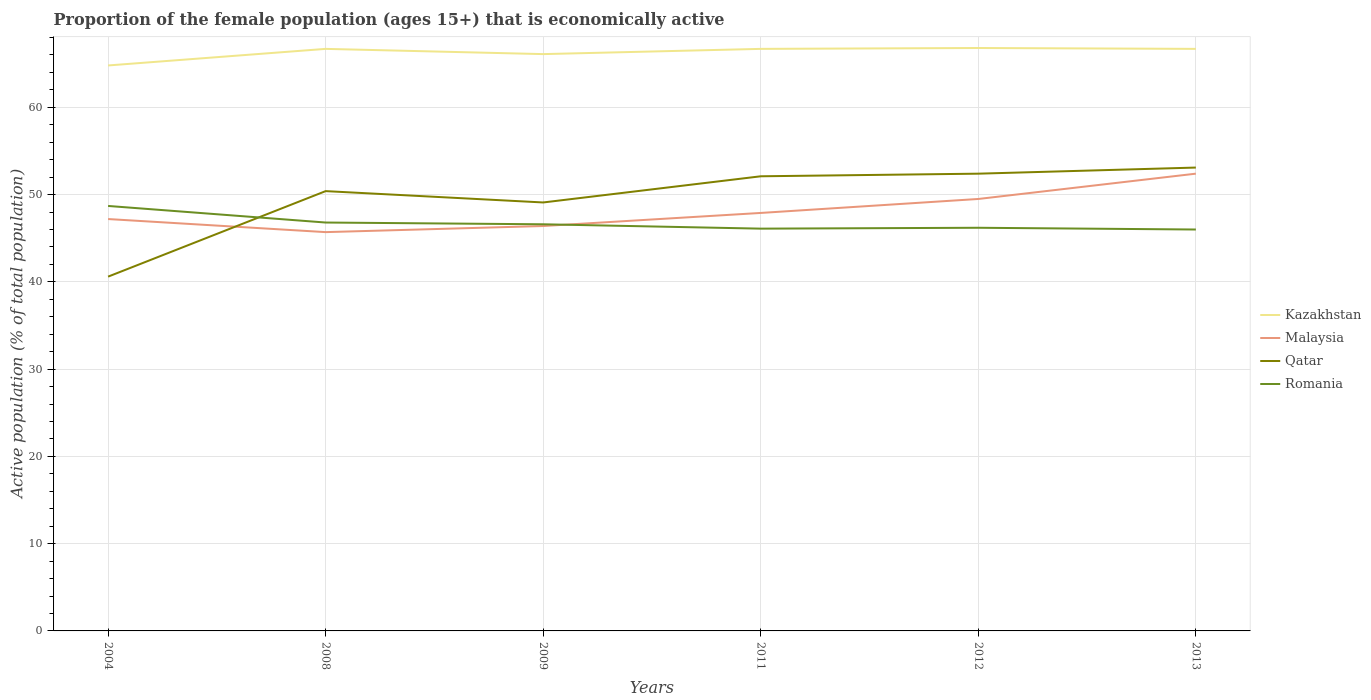Does the line corresponding to Malaysia intersect with the line corresponding to Qatar?
Your response must be concise. Yes. What is the total proportion of the female population that is economically active in Qatar in the graph?
Your answer should be very brief. -1. What is the difference between the highest and the lowest proportion of the female population that is economically active in Qatar?
Your answer should be very brief. 4. How many lines are there?
Make the answer very short. 4. How many years are there in the graph?
Make the answer very short. 6. What is the difference between two consecutive major ticks on the Y-axis?
Your response must be concise. 10. Are the values on the major ticks of Y-axis written in scientific E-notation?
Ensure brevity in your answer.  No. Where does the legend appear in the graph?
Provide a succinct answer. Center right. How many legend labels are there?
Your answer should be very brief. 4. How are the legend labels stacked?
Ensure brevity in your answer.  Vertical. What is the title of the graph?
Provide a short and direct response. Proportion of the female population (ages 15+) that is economically active. Does "Europe(developing only)" appear as one of the legend labels in the graph?
Provide a short and direct response. No. What is the label or title of the Y-axis?
Give a very brief answer. Active population (% of total population). What is the Active population (% of total population) of Kazakhstan in 2004?
Make the answer very short. 64.8. What is the Active population (% of total population) in Malaysia in 2004?
Provide a succinct answer. 47.2. What is the Active population (% of total population) in Qatar in 2004?
Keep it short and to the point. 40.6. What is the Active population (% of total population) in Romania in 2004?
Your answer should be very brief. 48.7. What is the Active population (% of total population) in Kazakhstan in 2008?
Give a very brief answer. 66.7. What is the Active population (% of total population) of Malaysia in 2008?
Provide a short and direct response. 45.7. What is the Active population (% of total population) of Qatar in 2008?
Ensure brevity in your answer.  50.4. What is the Active population (% of total population) of Romania in 2008?
Provide a short and direct response. 46.8. What is the Active population (% of total population) of Kazakhstan in 2009?
Your answer should be compact. 66.1. What is the Active population (% of total population) of Malaysia in 2009?
Your answer should be very brief. 46.4. What is the Active population (% of total population) in Qatar in 2009?
Your response must be concise. 49.1. What is the Active population (% of total population) in Romania in 2009?
Offer a very short reply. 46.6. What is the Active population (% of total population) in Kazakhstan in 2011?
Your answer should be very brief. 66.7. What is the Active population (% of total population) of Malaysia in 2011?
Provide a succinct answer. 47.9. What is the Active population (% of total population) of Qatar in 2011?
Your response must be concise. 52.1. What is the Active population (% of total population) in Romania in 2011?
Your answer should be very brief. 46.1. What is the Active population (% of total population) in Kazakhstan in 2012?
Make the answer very short. 66.8. What is the Active population (% of total population) of Malaysia in 2012?
Offer a very short reply. 49.5. What is the Active population (% of total population) in Qatar in 2012?
Your answer should be compact. 52.4. What is the Active population (% of total population) of Romania in 2012?
Your answer should be very brief. 46.2. What is the Active population (% of total population) of Kazakhstan in 2013?
Ensure brevity in your answer.  66.7. What is the Active population (% of total population) in Malaysia in 2013?
Offer a very short reply. 52.4. What is the Active population (% of total population) of Qatar in 2013?
Offer a terse response. 53.1. What is the Active population (% of total population) of Romania in 2013?
Offer a very short reply. 46. Across all years, what is the maximum Active population (% of total population) of Kazakhstan?
Your answer should be very brief. 66.8. Across all years, what is the maximum Active population (% of total population) in Malaysia?
Offer a very short reply. 52.4. Across all years, what is the maximum Active population (% of total population) of Qatar?
Your answer should be very brief. 53.1. Across all years, what is the maximum Active population (% of total population) of Romania?
Make the answer very short. 48.7. Across all years, what is the minimum Active population (% of total population) in Kazakhstan?
Give a very brief answer. 64.8. Across all years, what is the minimum Active population (% of total population) of Malaysia?
Offer a terse response. 45.7. Across all years, what is the minimum Active population (% of total population) of Qatar?
Provide a succinct answer. 40.6. Across all years, what is the minimum Active population (% of total population) of Romania?
Your answer should be very brief. 46. What is the total Active population (% of total population) in Kazakhstan in the graph?
Provide a succinct answer. 397.8. What is the total Active population (% of total population) in Malaysia in the graph?
Keep it short and to the point. 289.1. What is the total Active population (% of total population) of Qatar in the graph?
Give a very brief answer. 297.7. What is the total Active population (% of total population) of Romania in the graph?
Make the answer very short. 280.4. What is the difference between the Active population (% of total population) of Malaysia in 2004 and that in 2008?
Your answer should be compact. 1.5. What is the difference between the Active population (% of total population) in Qatar in 2004 and that in 2008?
Make the answer very short. -9.8. What is the difference between the Active population (% of total population) of Romania in 2004 and that in 2008?
Your response must be concise. 1.9. What is the difference between the Active population (% of total population) of Romania in 2004 and that in 2009?
Your response must be concise. 2.1. What is the difference between the Active population (% of total population) of Kazakhstan in 2004 and that in 2011?
Ensure brevity in your answer.  -1.9. What is the difference between the Active population (% of total population) of Malaysia in 2004 and that in 2011?
Offer a terse response. -0.7. What is the difference between the Active population (% of total population) of Qatar in 2004 and that in 2011?
Your response must be concise. -11.5. What is the difference between the Active population (% of total population) in Kazakhstan in 2004 and that in 2012?
Your response must be concise. -2. What is the difference between the Active population (% of total population) of Qatar in 2004 and that in 2012?
Provide a short and direct response. -11.8. What is the difference between the Active population (% of total population) in Malaysia in 2004 and that in 2013?
Provide a succinct answer. -5.2. What is the difference between the Active population (% of total population) of Romania in 2004 and that in 2013?
Give a very brief answer. 2.7. What is the difference between the Active population (% of total population) in Kazakhstan in 2008 and that in 2009?
Your response must be concise. 0.6. What is the difference between the Active population (% of total population) in Qatar in 2008 and that in 2009?
Give a very brief answer. 1.3. What is the difference between the Active population (% of total population) in Romania in 2008 and that in 2009?
Your answer should be very brief. 0.2. What is the difference between the Active population (% of total population) of Kazakhstan in 2008 and that in 2011?
Provide a succinct answer. 0. What is the difference between the Active population (% of total population) of Malaysia in 2008 and that in 2011?
Your answer should be compact. -2.2. What is the difference between the Active population (% of total population) in Romania in 2008 and that in 2011?
Your response must be concise. 0.7. What is the difference between the Active population (% of total population) in Malaysia in 2008 and that in 2012?
Give a very brief answer. -3.8. What is the difference between the Active population (% of total population) in Malaysia in 2008 and that in 2013?
Offer a terse response. -6.7. What is the difference between the Active population (% of total population) in Malaysia in 2009 and that in 2011?
Ensure brevity in your answer.  -1.5. What is the difference between the Active population (% of total population) in Qatar in 2009 and that in 2011?
Offer a very short reply. -3. What is the difference between the Active population (% of total population) of Romania in 2011 and that in 2012?
Ensure brevity in your answer.  -0.1. What is the difference between the Active population (% of total population) of Kazakhstan in 2011 and that in 2013?
Your answer should be very brief. 0. What is the difference between the Active population (% of total population) in Malaysia in 2011 and that in 2013?
Provide a short and direct response. -4.5. What is the difference between the Active population (% of total population) of Romania in 2011 and that in 2013?
Provide a succinct answer. 0.1. What is the difference between the Active population (% of total population) in Qatar in 2012 and that in 2013?
Make the answer very short. -0.7. What is the difference between the Active population (% of total population) of Romania in 2012 and that in 2013?
Offer a terse response. 0.2. What is the difference between the Active population (% of total population) of Kazakhstan in 2004 and the Active population (% of total population) of Malaysia in 2008?
Your answer should be compact. 19.1. What is the difference between the Active population (% of total population) of Kazakhstan in 2004 and the Active population (% of total population) of Malaysia in 2009?
Offer a terse response. 18.4. What is the difference between the Active population (% of total population) in Kazakhstan in 2004 and the Active population (% of total population) in Qatar in 2009?
Your response must be concise. 15.7. What is the difference between the Active population (% of total population) of Kazakhstan in 2004 and the Active population (% of total population) of Romania in 2009?
Make the answer very short. 18.2. What is the difference between the Active population (% of total population) of Malaysia in 2004 and the Active population (% of total population) of Qatar in 2009?
Offer a terse response. -1.9. What is the difference between the Active population (% of total population) of Qatar in 2004 and the Active population (% of total population) of Romania in 2009?
Keep it short and to the point. -6. What is the difference between the Active population (% of total population) of Kazakhstan in 2004 and the Active population (% of total population) of Malaysia in 2011?
Offer a very short reply. 16.9. What is the difference between the Active population (% of total population) of Kazakhstan in 2004 and the Active population (% of total population) of Qatar in 2011?
Offer a terse response. 12.7. What is the difference between the Active population (% of total population) in Malaysia in 2004 and the Active population (% of total population) in Romania in 2011?
Your answer should be very brief. 1.1. What is the difference between the Active population (% of total population) of Qatar in 2004 and the Active population (% of total population) of Romania in 2011?
Keep it short and to the point. -5.5. What is the difference between the Active population (% of total population) of Malaysia in 2004 and the Active population (% of total population) of Qatar in 2012?
Ensure brevity in your answer.  -5.2. What is the difference between the Active population (% of total population) of Kazakhstan in 2004 and the Active population (% of total population) of Malaysia in 2013?
Your answer should be compact. 12.4. What is the difference between the Active population (% of total population) of Malaysia in 2004 and the Active population (% of total population) of Romania in 2013?
Offer a terse response. 1.2. What is the difference between the Active population (% of total population) in Kazakhstan in 2008 and the Active population (% of total population) in Malaysia in 2009?
Offer a very short reply. 20.3. What is the difference between the Active population (% of total population) of Kazakhstan in 2008 and the Active population (% of total population) of Qatar in 2009?
Ensure brevity in your answer.  17.6. What is the difference between the Active population (% of total population) in Kazakhstan in 2008 and the Active population (% of total population) in Romania in 2009?
Your answer should be very brief. 20.1. What is the difference between the Active population (% of total population) of Malaysia in 2008 and the Active population (% of total population) of Qatar in 2009?
Make the answer very short. -3.4. What is the difference between the Active population (% of total population) of Qatar in 2008 and the Active population (% of total population) of Romania in 2009?
Your answer should be very brief. 3.8. What is the difference between the Active population (% of total population) in Kazakhstan in 2008 and the Active population (% of total population) in Romania in 2011?
Give a very brief answer. 20.6. What is the difference between the Active population (% of total population) in Malaysia in 2008 and the Active population (% of total population) in Qatar in 2011?
Provide a succinct answer. -6.4. What is the difference between the Active population (% of total population) in Malaysia in 2008 and the Active population (% of total population) in Romania in 2011?
Your response must be concise. -0.4. What is the difference between the Active population (% of total population) in Kazakhstan in 2008 and the Active population (% of total population) in Romania in 2012?
Your answer should be very brief. 20.5. What is the difference between the Active population (% of total population) of Malaysia in 2008 and the Active population (% of total population) of Qatar in 2012?
Your response must be concise. -6.7. What is the difference between the Active population (% of total population) of Qatar in 2008 and the Active population (% of total population) of Romania in 2012?
Keep it short and to the point. 4.2. What is the difference between the Active population (% of total population) of Kazakhstan in 2008 and the Active population (% of total population) of Romania in 2013?
Give a very brief answer. 20.7. What is the difference between the Active population (% of total population) in Malaysia in 2008 and the Active population (% of total population) in Qatar in 2013?
Provide a succinct answer. -7.4. What is the difference between the Active population (% of total population) in Qatar in 2008 and the Active population (% of total population) in Romania in 2013?
Ensure brevity in your answer.  4.4. What is the difference between the Active population (% of total population) of Kazakhstan in 2009 and the Active population (% of total population) of Malaysia in 2011?
Offer a very short reply. 18.2. What is the difference between the Active population (% of total population) in Kazakhstan in 2009 and the Active population (% of total population) in Qatar in 2011?
Give a very brief answer. 14. What is the difference between the Active population (% of total population) in Kazakhstan in 2009 and the Active population (% of total population) in Romania in 2011?
Provide a short and direct response. 20. What is the difference between the Active population (% of total population) of Malaysia in 2009 and the Active population (% of total population) of Qatar in 2011?
Provide a short and direct response. -5.7. What is the difference between the Active population (% of total population) of Malaysia in 2009 and the Active population (% of total population) of Romania in 2011?
Your response must be concise. 0.3. What is the difference between the Active population (% of total population) of Qatar in 2009 and the Active population (% of total population) of Romania in 2011?
Offer a very short reply. 3. What is the difference between the Active population (% of total population) of Kazakhstan in 2009 and the Active population (% of total population) of Qatar in 2012?
Your answer should be very brief. 13.7. What is the difference between the Active population (% of total population) of Kazakhstan in 2009 and the Active population (% of total population) of Romania in 2012?
Your answer should be very brief. 19.9. What is the difference between the Active population (% of total population) in Malaysia in 2009 and the Active population (% of total population) in Romania in 2012?
Your answer should be very brief. 0.2. What is the difference between the Active population (% of total population) in Kazakhstan in 2009 and the Active population (% of total population) in Malaysia in 2013?
Give a very brief answer. 13.7. What is the difference between the Active population (% of total population) in Kazakhstan in 2009 and the Active population (% of total population) in Romania in 2013?
Make the answer very short. 20.1. What is the difference between the Active population (% of total population) of Malaysia in 2009 and the Active population (% of total population) of Qatar in 2013?
Give a very brief answer. -6.7. What is the difference between the Active population (% of total population) of Malaysia in 2009 and the Active population (% of total population) of Romania in 2013?
Offer a terse response. 0.4. What is the difference between the Active population (% of total population) of Qatar in 2009 and the Active population (% of total population) of Romania in 2013?
Your answer should be very brief. 3.1. What is the difference between the Active population (% of total population) in Kazakhstan in 2011 and the Active population (% of total population) in Qatar in 2012?
Provide a succinct answer. 14.3. What is the difference between the Active population (% of total population) in Kazakhstan in 2011 and the Active population (% of total population) in Romania in 2012?
Your answer should be compact. 20.5. What is the difference between the Active population (% of total population) of Malaysia in 2011 and the Active population (% of total population) of Romania in 2012?
Provide a succinct answer. 1.7. What is the difference between the Active population (% of total population) in Kazakhstan in 2011 and the Active population (% of total population) in Romania in 2013?
Keep it short and to the point. 20.7. What is the difference between the Active population (% of total population) in Malaysia in 2011 and the Active population (% of total population) in Qatar in 2013?
Keep it short and to the point. -5.2. What is the difference between the Active population (% of total population) in Malaysia in 2011 and the Active population (% of total population) in Romania in 2013?
Provide a short and direct response. 1.9. What is the difference between the Active population (% of total population) of Qatar in 2011 and the Active population (% of total population) of Romania in 2013?
Ensure brevity in your answer.  6.1. What is the difference between the Active population (% of total population) of Kazakhstan in 2012 and the Active population (% of total population) of Romania in 2013?
Provide a succinct answer. 20.8. What is the difference between the Active population (% of total population) of Malaysia in 2012 and the Active population (% of total population) of Qatar in 2013?
Provide a short and direct response. -3.6. What is the average Active population (% of total population) in Kazakhstan per year?
Keep it short and to the point. 66.3. What is the average Active population (% of total population) of Malaysia per year?
Your answer should be very brief. 48.18. What is the average Active population (% of total population) of Qatar per year?
Provide a short and direct response. 49.62. What is the average Active population (% of total population) in Romania per year?
Your answer should be compact. 46.73. In the year 2004, what is the difference between the Active population (% of total population) of Kazakhstan and Active population (% of total population) of Malaysia?
Make the answer very short. 17.6. In the year 2004, what is the difference between the Active population (% of total population) of Kazakhstan and Active population (% of total population) of Qatar?
Provide a succinct answer. 24.2. In the year 2004, what is the difference between the Active population (% of total population) in Kazakhstan and Active population (% of total population) in Romania?
Provide a succinct answer. 16.1. In the year 2004, what is the difference between the Active population (% of total population) in Malaysia and Active population (% of total population) in Romania?
Provide a short and direct response. -1.5. In the year 2008, what is the difference between the Active population (% of total population) in Kazakhstan and Active population (% of total population) in Romania?
Make the answer very short. 19.9. In the year 2008, what is the difference between the Active population (% of total population) of Malaysia and Active population (% of total population) of Qatar?
Offer a very short reply. -4.7. In the year 2008, what is the difference between the Active population (% of total population) of Qatar and Active population (% of total population) of Romania?
Give a very brief answer. 3.6. In the year 2009, what is the difference between the Active population (% of total population) of Kazakhstan and Active population (% of total population) of Malaysia?
Offer a terse response. 19.7. In the year 2009, what is the difference between the Active population (% of total population) in Malaysia and Active population (% of total population) in Romania?
Give a very brief answer. -0.2. In the year 2011, what is the difference between the Active population (% of total population) in Kazakhstan and Active population (% of total population) in Malaysia?
Offer a very short reply. 18.8. In the year 2011, what is the difference between the Active population (% of total population) of Kazakhstan and Active population (% of total population) of Qatar?
Offer a very short reply. 14.6. In the year 2011, what is the difference between the Active population (% of total population) in Kazakhstan and Active population (% of total population) in Romania?
Give a very brief answer. 20.6. In the year 2011, what is the difference between the Active population (% of total population) of Malaysia and Active population (% of total population) of Qatar?
Your answer should be very brief. -4.2. In the year 2011, what is the difference between the Active population (% of total population) in Qatar and Active population (% of total population) in Romania?
Provide a short and direct response. 6. In the year 2012, what is the difference between the Active population (% of total population) of Kazakhstan and Active population (% of total population) of Malaysia?
Your response must be concise. 17.3. In the year 2012, what is the difference between the Active population (% of total population) of Kazakhstan and Active population (% of total population) of Romania?
Offer a very short reply. 20.6. In the year 2012, what is the difference between the Active population (% of total population) of Malaysia and Active population (% of total population) of Qatar?
Provide a succinct answer. -2.9. In the year 2012, what is the difference between the Active population (% of total population) of Qatar and Active population (% of total population) of Romania?
Give a very brief answer. 6.2. In the year 2013, what is the difference between the Active population (% of total population) in Kazakhstan and Active population (% of total population) in Malaysia?
Your response must be concise. 14.3. In the year 2013, what is the difference between the Active population (% of total population) in Kazakhstan and Active population (% of total population) in Qatar?
Provide a succinct answer. 13.6. In the year 2013, what is the difference between the Active population (% of total population) in Kazakhstan and Active population (% of total population) in Romania?
Your response must be concise. 20.7. In the year 2013, what is the difference between the Active population (% of total population) of Malaysia and Active population (% of total population) of Qatar?
Your answer should be compact. -0.7. In the year 2013, what is the difference between the Active population (% of total population) in Malaysia and Active population (% of total population) in Romania?
Give a very brief answer. 6.4. What is the ratio of the Active population (% of total population) in Kazakhstan in 2004 to that in 2008?
Offer a terse response. 0.97. What is the ratio of the Active population (% of total population) in Malaysia in 2004 to that in 2008?
Ensure brevity in your answer.  1.03. What is the ratio of the Active population (% of total population) of Qatar in 2004 to that in 2008?
Provide a succinct answer. 0.81. What is the ratio of the Active population (% of total population) in Romania in 2004 to that in 2008?
Offer a very short reply. 1.04. What is the ratio of the Active population (% of total population) of Kazakhstan in 2004 to that in 2009?
Your response must be concise. 0.98. What is the ratio of the Active population (% of total population) of Malaysia in 2004 to that in 2009?
Provide a short and direct response. 1.02. What is the ratio of the Active population (% of total population) in Qatar in 2004 to that in 2009?
Your answer should be compact. 0.83. What is the ratio of the Active population (% of total population) in Romania in 2004 to that in 2009?
Provide a short and direct response. 1.05. What is the ratio of the Active population (% of total population) in Kazakhstan in 2004 to that in 2011?
Provide a short and direct response. 0.97. What is the ratio of the Active population (% of total population) of Malaysia in 2004 to that in 2011?
Make the answer very short. 0.99. What is the ratio of the Active population (% of total population) of Qatar in 2004 to that in 2011?
Ensure brevity in your answer.  0.78. What is the ratio of the Active population (% of total population) of Romania in 2004 to that in 2011?
Your answer should be compact. 1.06. What is the ratio of the Active population (% of total population) of Kazakhstan in 2004 to that in 2012?
Your answer should be compact. 0.97. What is the ratio of the Active population (% of total population) in Malaysia in 2004 to that in 2012?
Your answer should be very brief. 0.95. What is the ratio of the Active population (% of total population) in Qatar in 2004 to that in 2012?
Provide a short and direct response. 0.77. What is the ratio of the Active population (% of total population) of Romania in 2004 to that in 2012?
Offer a terse response. 1.05. What is the ratio of the Active population (% of total population) of Kazakhstan in 2004 to that in 2013?
Provide a succinct answer. 0.97. What is the ratio of the Active population (% of total population) of Malaysia in 2004 to that in 2013?
Your response must be concise. 0.9. What is the ratio of the Active population (% of total population) in Qatar in 2004 to that in 2013?
Provide a succinct answer. 0.76. What is the ratio of the Active population (% of total population) of Romania in 2004 to that in 2013?
Keep it short and to the point. 1.06. What is the ratio of the Active population (% of total population) in Kazakhstan in 2008 to that in 2009?
Ensure brevity in your answer.  1.01. What is the ratio of the Active population (% of total population) of Malaysia in 2008 to that in 2009?
Offer a terse response. 0.98. What is the ratio of the Active population (% of total population) of Qatar in 2008 to that in 2009?
Keep it short and to the point. 1.03. What is the ratio of the Active population (% of total population) of Romania in 2008 to that in 2009?
Provide a succinct answer. 1. What is the ratio of the Active population (% of total population) in Malaysia in 2008 to that in 2011?
Keep it short and to the point. 0.95. What is the ratio of the Active population (% of total population) in Qatar in 2008 to that in 2011?
Provide a succinct answer. 0.97. What is the ratio of the Active population (% of total population) of Romania in 2008 to that in 2011?
Your response must be concise. 1.02. What is the ratio of the Active population (% of total population) in Kazakhstan in 2008 to that in 2012?
Your response must be concise. 1. What is the ratio of the Active population (% of total population) of Malaysia in 2008 to that in 2012?
Ensure brevity in your answer.  0.92. What is the ratio of the Active population (% of total population) of Qatar in 2008 to that in 2012?
Your answer should be very brief. 0.96. What is the ratio of the Active population (% of total population) of Malaysia in 2008 to that in 2013?
Make the answer very short. 0.87. What is the ratio of the Active population (% of total population) of Qatar in 2008 to that in 2013?
Keep it short and to the point. 0.95. What is the ratio of the Active population (% of total population) of Romania in 2008 to that in 2013?
Ensure brevity in your answer.  1.02. What is the ratio of the Active population (% of total population) of Malaysia in 2009 to that in 2011?
Make the answer very short. 0.97. What is the ratio of the Active population (% of total population) of Qatar in 2009 to that in 2011?
Your answer should be very brief. 0.94. What is the ratio of the Active population (% of total population) in Romania in 2009 to that in 2011?
Make the answer very short. 1.01. What is the ratio of the Active population (% of total population) in Malaysia in 2009 to that in 2012?
Offer a terse response. 0.94. What is the ratio of the Active population (% of total population) in Qatar in 2009 to that in 2012?
Your response must be concise. 0.94. What is the ratio of the Active population (% of total population) of Romania in 2009 to that in 2012?
Provide a short and direct response. 1.01. What is the ratio of the Active population (% of total population) in Kazakhstan in 2009 to that in 2013?
Offer a terse response. 0.99. What is the ratio of the Active population (% of total population) in Malaysia in 2009 to that in 2013?
Keep it short and to the point. 0.89. What is the ratio of the Active population (% of total population) in Qatar in 2009 to that in 2013?
Give a very brief answer. 0.92. What is the ratio of the Active population (% of total population) in Kazakhstan in 2011 to that in 2012?
Your response must be concise. 1. What is the ratio of the Active population (% of total population) in Malaysia in 2011 to that in 2012?
Your response must be concise. 0.97. What is the ratio of the Active population (% of total population) of Romania in 2011 to that in 2012?
Keep it short and to the point. 1. What is the ratio of the Active population (% of total population) in Kazakhstan in 2011 to that in 2013?
Make the answer very short. 1. What is the ratio of the Active population (% of total population) of Malaysia in 2011 to that in 2013?
Your answer should be very brief. 0.91. What is the ratio of the Active population (% of total population) in Qatar in 2011 to that in 2013?
Provide a succinct answer. 0.98. What is the ratio of the Active population (% of total population) of Romania in 2011 to that in 2013?
Your answer should be compact. 1. What is the ratio of the Active population (% of total population) in Kazakhstan in 2012 to that in 2013?
Your answer should be compact. 1. What is the ratio of the Active population (% of total population) in Malaysia in 2012 to that in 2013?
Your answer should be compact. 0.94. What is the difference between the highest and the second highest Active population (% of total population) in Malaysia?
Your answer should be compact. 2.9. What is the difference between the highest and the lowest Active population (% of total population) of Kazakhstan?
Offer a terse response. 2. 